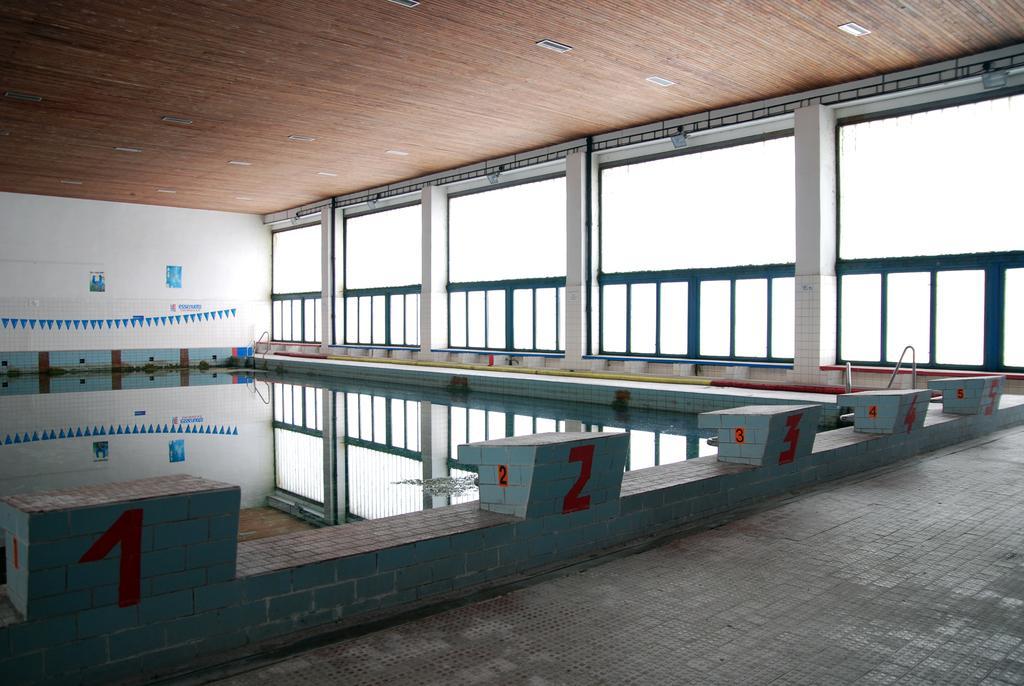Can you describe this image briefly? In the foreground of this picture we can see the pavement and the numbers on the objects. At the top there is a roof and the ceiling lights. In the background we can see the pictures of some objects and we can see the wall, windows and some other objects. 